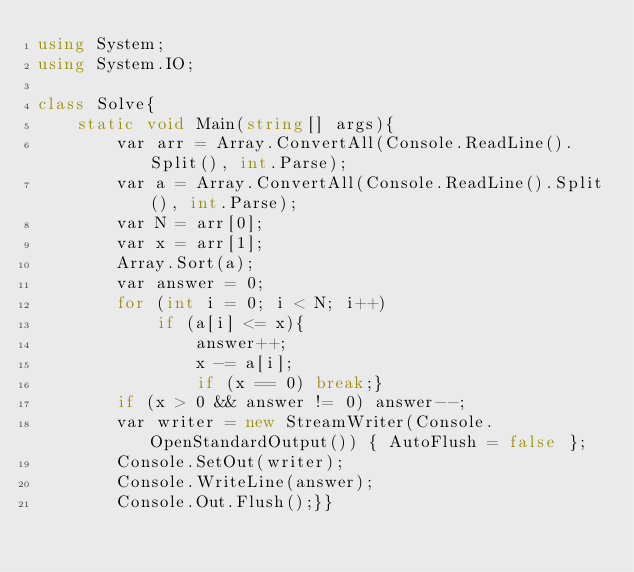Convert code to text. <code><loc_0><loc_0><loc_500><loc_500><_C#_>using System;
using System.IO;

class Solve{
    static void Main(string[] args){
        var arr = Array.ConvertAll(Console.ReadLine().Split(), int.Parse);
        var a = Array.ConvertAll(Console.ReadLine().Split(), int.Parse);
        var N = arr[0];
        var x = arr[1];
        Array.Sort(a);
        var answer = 0;
        for (int i = 0; i < N; i++)
            if (a[i] <= x){
                answer++;
                x -= a[i];
                if (x == 0) break;}
        if (x > 0 && answer != 0) answer--;
        var writer = new StreamWriter(Console.OpenStandardOutput()) { AutoFlush = false };
        Console.SetOut(writer);
        Console.WriteLine(answer);
        Console.Out.Flush();}}</code> 